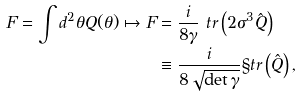<formula> <loc_0><loc_0><loc_500><loc_500>F = \int d ^ { 2 } \theta Q ( \theta ) \mapsto F & = \frac { i } { 8 \gamma } \ t r \left ( 2 \sigma ^ { 3 } \hat { Q } \right ) \\ & \equiv \frac { i } { 8 \sqrt { \det \gamma } } \S t r \left ( \hat { Q } \right ) ,</formula> 